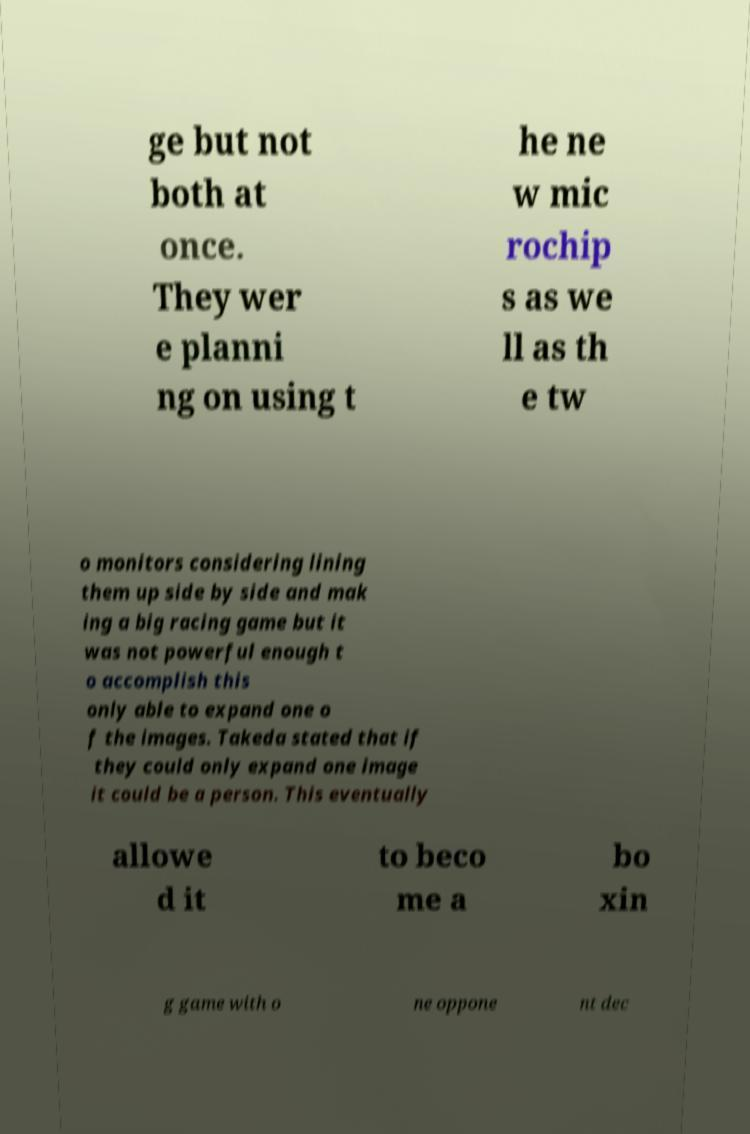Could you extract and type out the text from this image? ge but not both at once. They wer e planni ng on using t he ne w mic rochip s as we ll as th e tw o monitors considering lining them up side by side and mak ing a big racing game but it was not powerful enough t o accomplish this only able to expand one o f the images. Takeda stated that if they could only expand one image it could be a person. This eventually allowe d it to beco me a bo xin g game with o ne oppone nt dec 